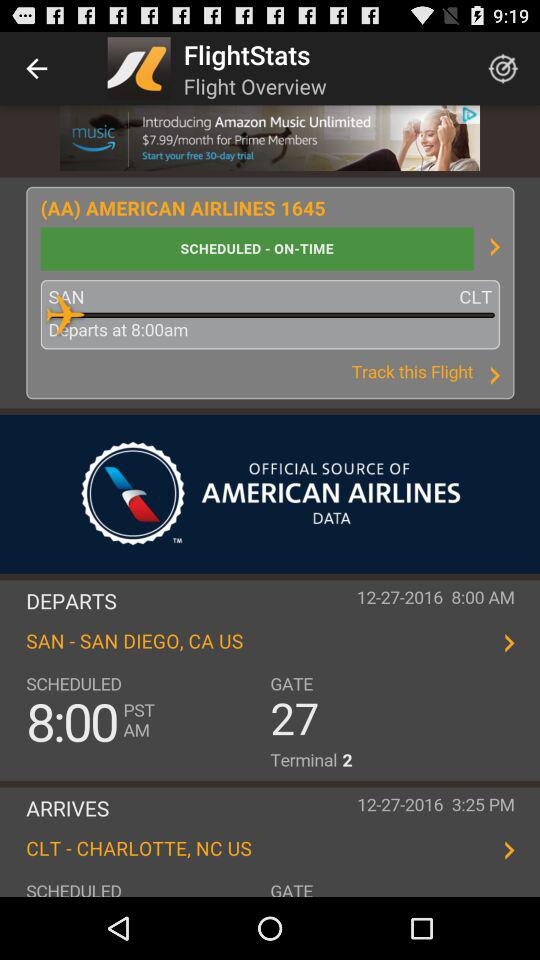What is the name of the airline that is operating this flight?
Answer the question using a single word or phrase. American Airlines 